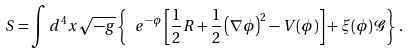Convert formula to latex. <formula><loc_0><loc_0><loc_500><loc_500>S = \int d ^ { 4 } x \sqrt { - g } \left \{ \ e ^ { - \phi } \left [ \frac { 1 } { 2 } R + \frac { 1 } { 2 } \left ( \nabla \phi \right ) ^ { 2 } - V ( \phi ) \right ] + \xi ( \phi ) \mathcal { G } \right \} \, .</formula> 